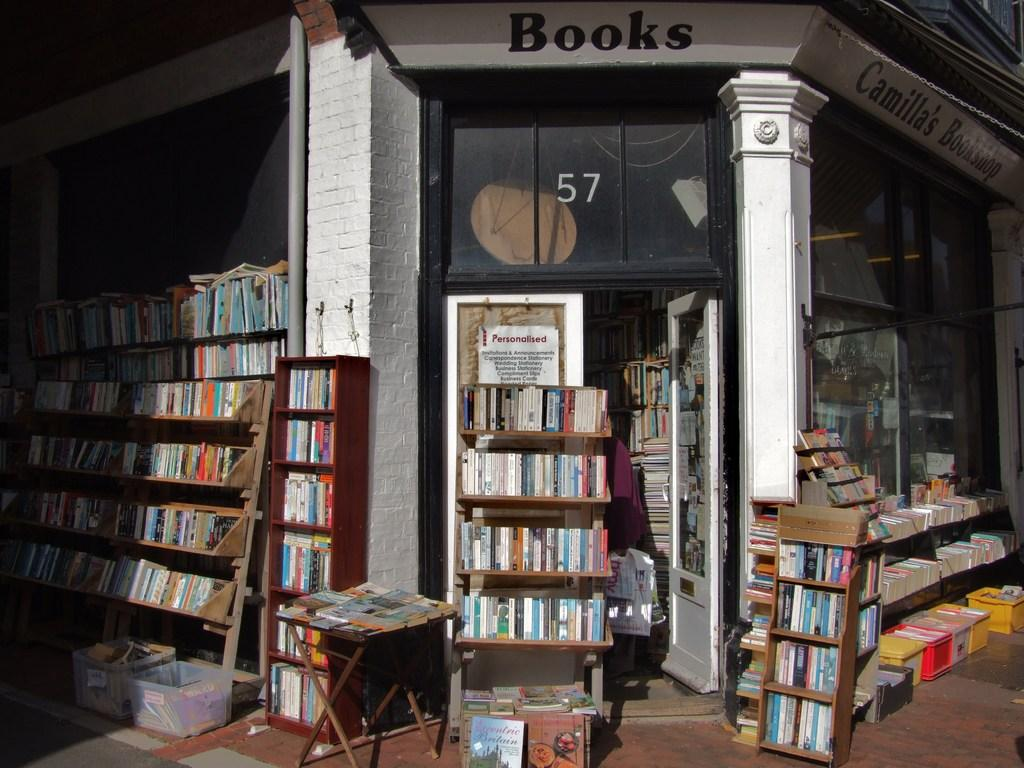<image>
Provide a brief description of the given image. Shelves and shelves of books are outside Camilla's Bookshop. 